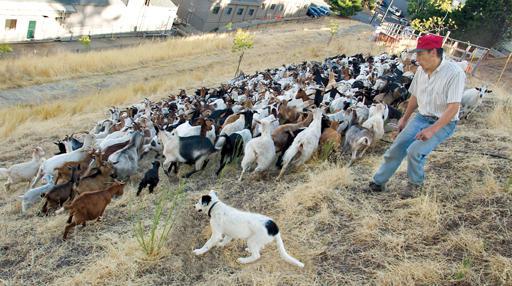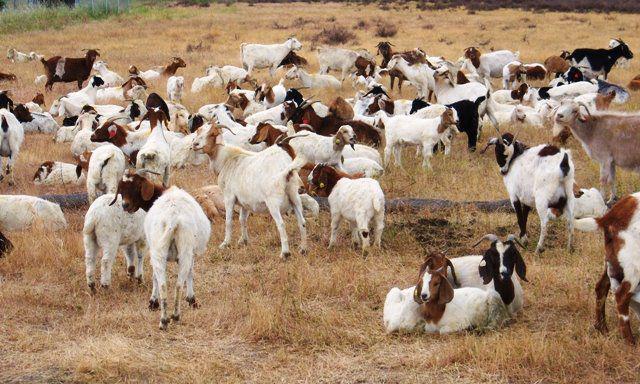The first image is the image on the left, the second image is the image on the right. For the images shown, is this caption "A dog has at least one paw in the air." true? Answer yes or no. No. The first image is the image on the left, the second image is the image on the right. Considering the images on both sides, is "There are two dogs in the image on the right" valid? Answer yes or no. No. 